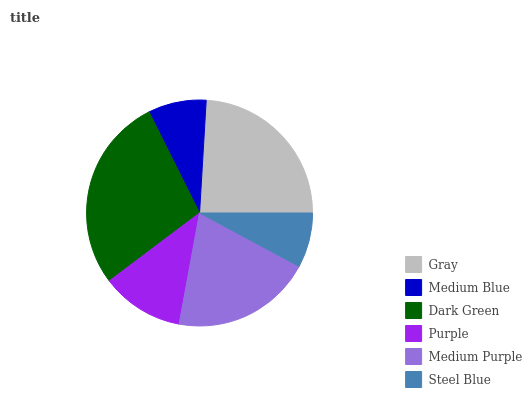Is Steel Blue the minimum?
Answer yes or no. Yes. Is Dark Green the maximum?
Answer yes or no. Yes. Is Medium Blue the minimum?
Answer yes or no. No. Is Medium Blue the maximum?
Answer yes or no. No. Is Gray greater than Medium Blue?
Answer yes or no. Yes. Is Medium Blue less than Gray?
Answer yes or no. Yes. Is Medium Blue greater than Gray?
Answer yes or no. No. Is Gray less than Medium Blue?
Answer yes or no. No. Is Medium Purple the high median?
Answer yes or no. Yes. Is Purple the low median?
Answer yes or no. Yes. Is Dark Green the high median?
Answer yes or no. No. Is Medium Purple the low median?
Answer yes or no. No. 